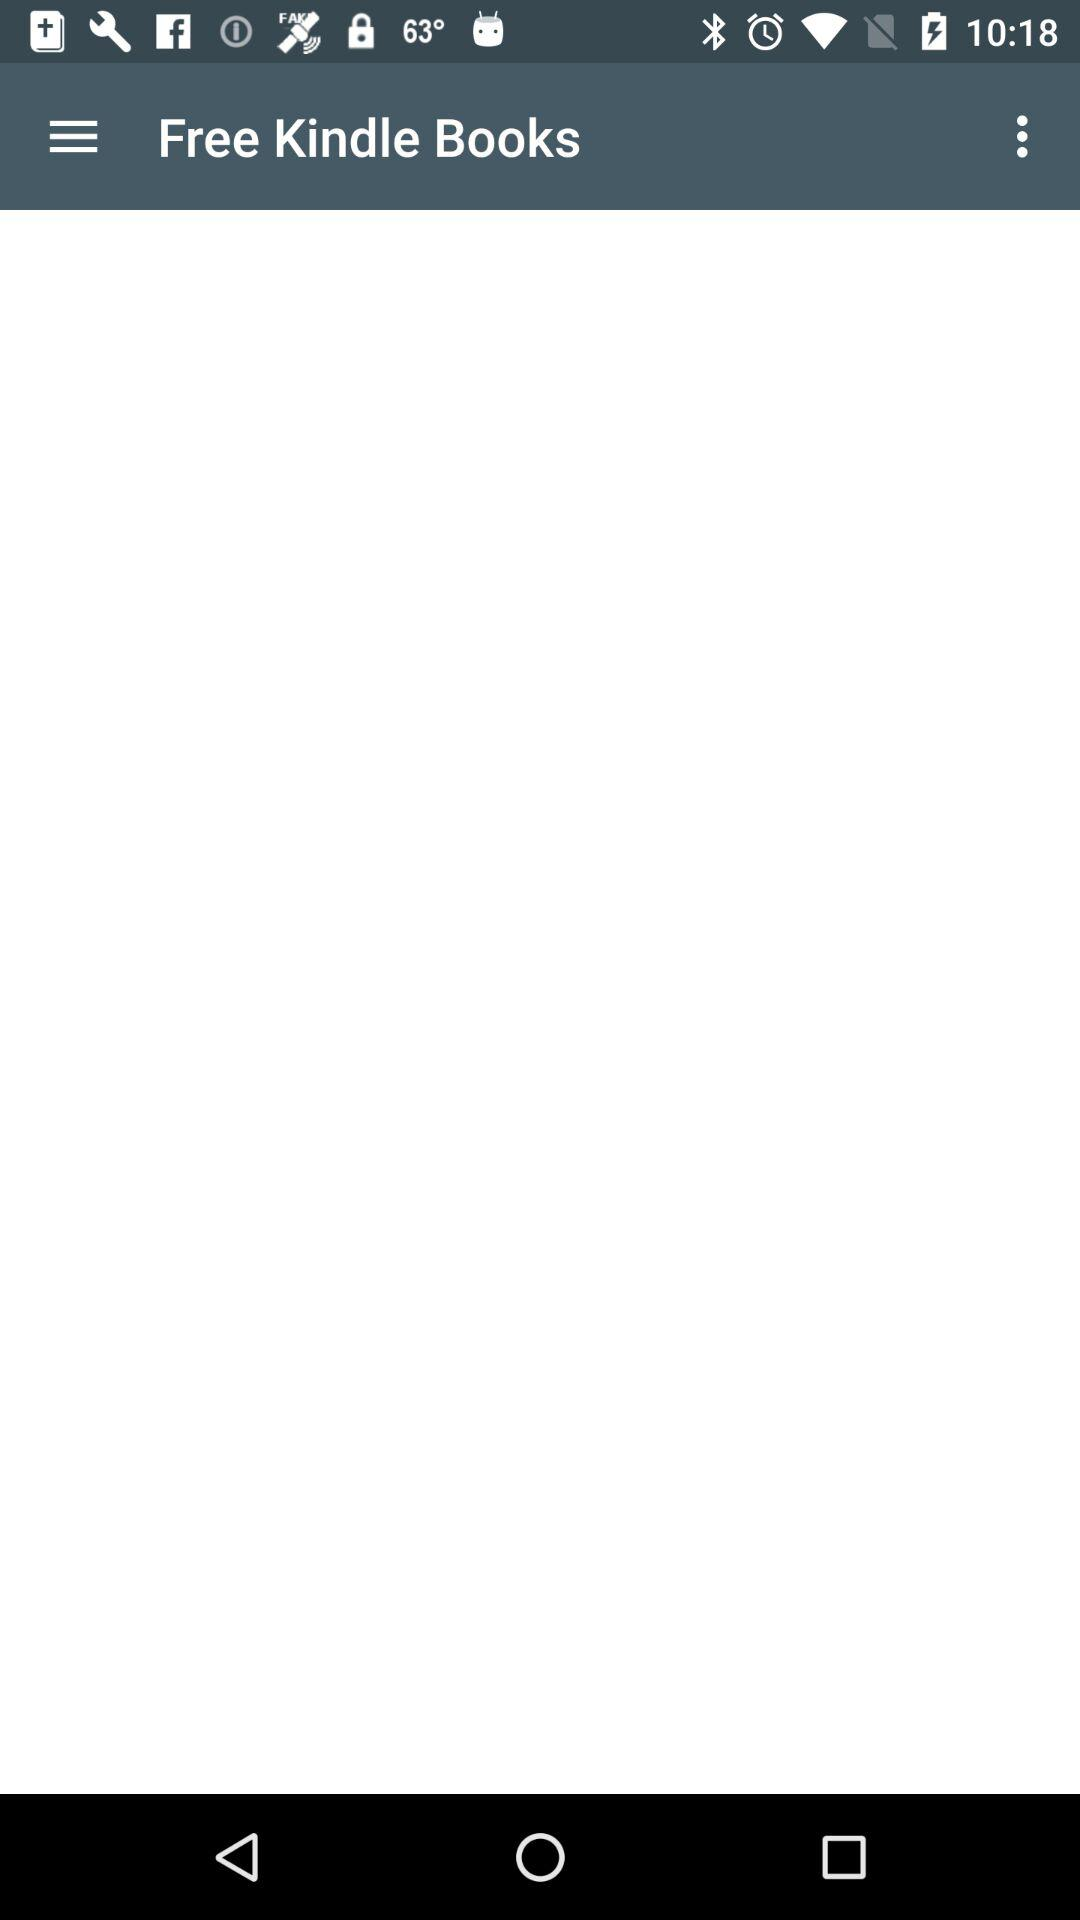What is the name of the application?
When the provided information is insufficient, respond with <no answer>. <no answer> 